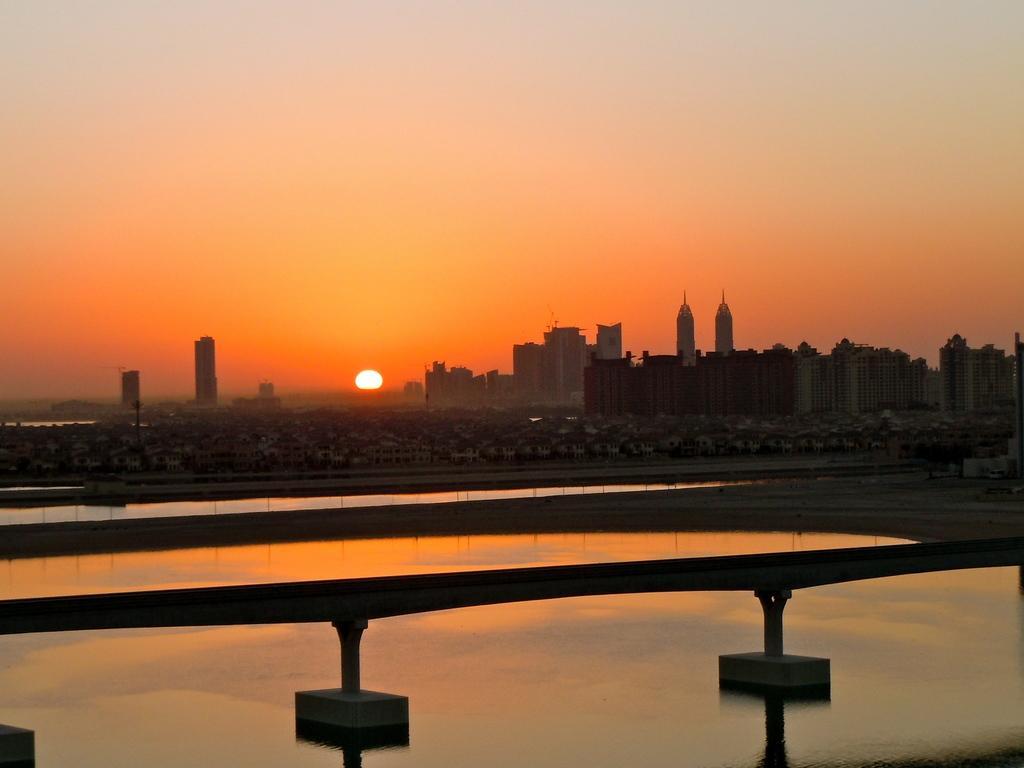Describe this image in one or two sentences. In the image we can see there are the buildings, water and the barrier. We can even see the sky and the sun. 